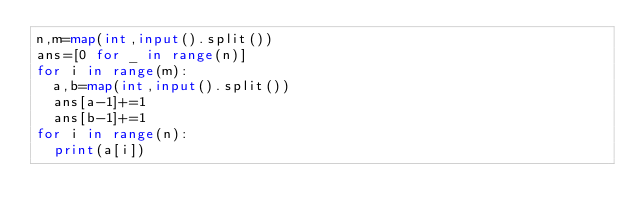<code> <loc_0><loc_0><loc_500><loc_500><_Python_>n,m=map(int,input().split())
ans=[0 for _ in range(n)]
for i in range(m):
  a,b=map(int,input().split())
  ans[a-1]+=1
  ans[b-1]+=1
for i in range(n):
  print(a[i])</code> 